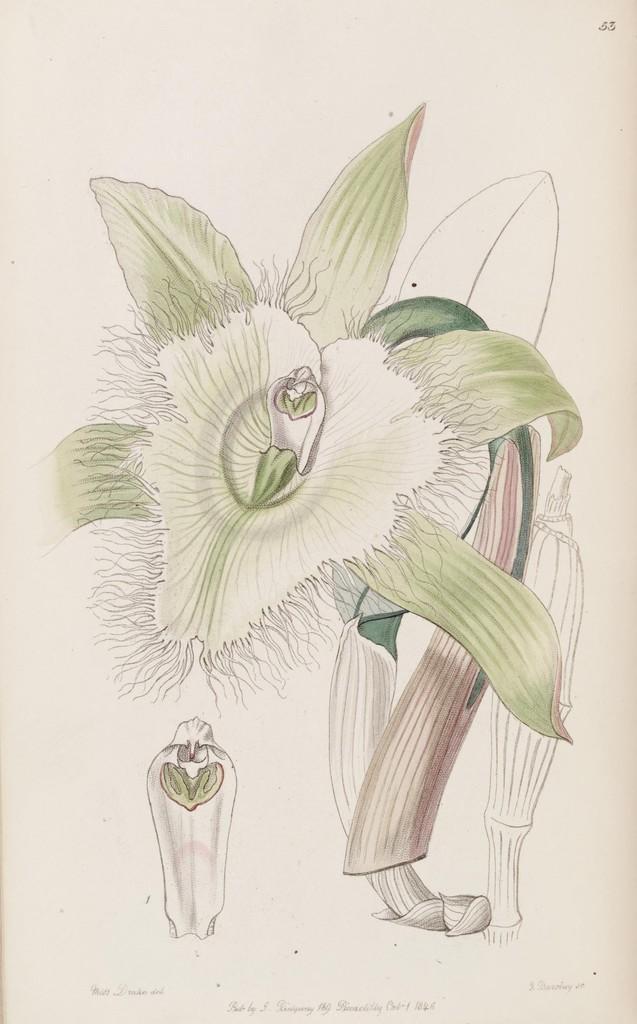Describe this image in one or two sentences. In this image I can see the drawing of a flower to the plant and a flower bud on the cream colored paper. 